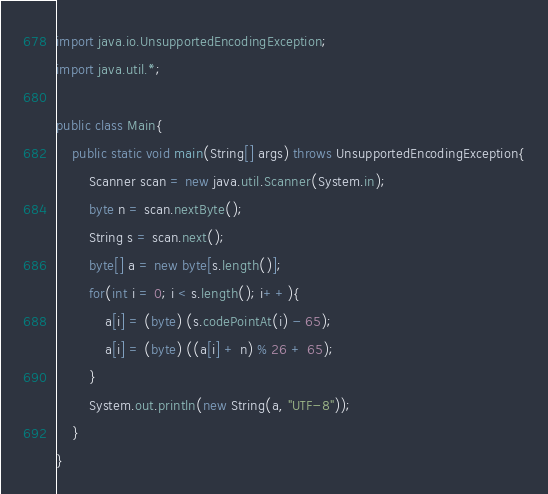<code> <loc_0><loc_0><loc_500><loc_500><_Java_>import java.io.UnsupportedEncodingException;
import java.util.*;

public class Main{
    public static void main(String[] args) throws UnsupportedEncodingException{
        Scanner scan = new java.util.Scanner(System.in);
        byte n = scan.nextByte();
        String s = scan.next();
        byte[] a = new byte[s.length()];
        for(int i = 0; i < s.length(); i++){
            a[i] = (byte) (s.codePointAt(i) - 65);
            a[i] = (byte) ((a[i] + n) % 26 + 65);
        }
        System.out.println(new String(a, "UTF-8"));
    }
}</code> 